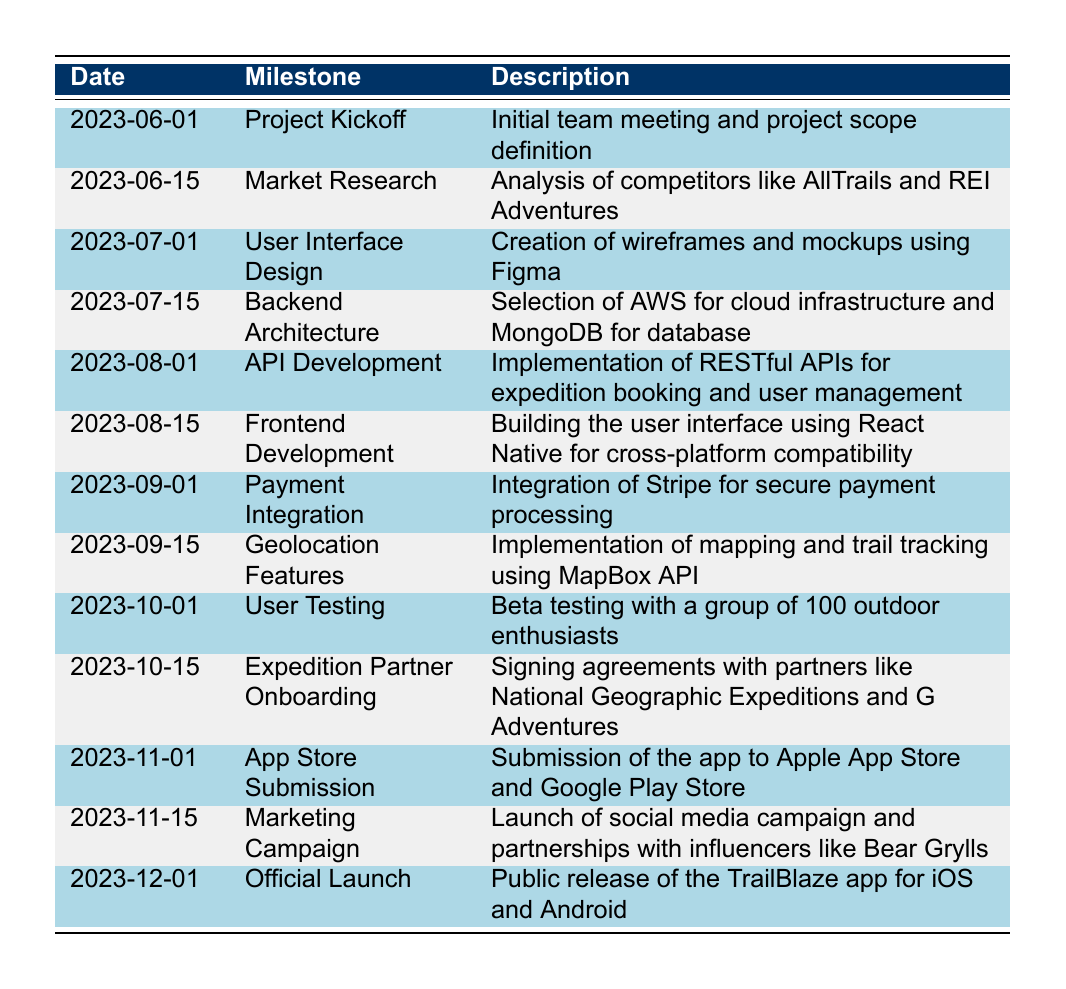What milestone is scheduled for August 1, 2023? The table shows the timeline of the project, and by looking at the date column for August 1, 2023, we can see that the corresponding milestone is "API Development."
Answer: API Development What is the description of the milestone on November 15, 2023? By checking the row for November 15, 2023, we find that the milestone is "Marketing Campaign" and the description is "Launch of social media campaign and partnerships with influencers like Bear Grylls."
Answer: Launch of social media campaign and partnerships with influencers like Bear Grylls How many milestones are scheduled before user testing? By counting the milestones listed before the date "2023-10-01" (User Testing), we can see there are seven milestones: Project Kickoff, Market Research, User Interface Design, Backend Architecture, API Development, Frontend Development, and Payment Integration.
Answer: 7 Is there any milestone scheduled after the official launch? The last entry in the table is for December 1, 2023, which indicates the Official Launch. Since there are no entries after this date in the table, the answer is no.
Answer: No Which milestone comes just before payment integration? Looking at the date of payment integration, which is September 1, 2023, we can see that the previous milestone is "Frontend Development" scheduled for August 15, 2023.
Answer: Frontend Development How many days are there between the Project Kickoff and the Official Launch? The Project Kickoff is on June 1, 2023, and the Official Launch is on December 1, 2023. There are 6 months (June to November) and 1 day in December, which is a total of 183 days (30 days for June, 31 for July, 31 for August, 30 for September, 31 for October, and 30 for November).
Answer: 183 days What percentage of the timeline includes milestones focused specifically on development (Design, Architecture, API, Frontend, Payment)? The total number of milestones in the timeline is 13. The milestones that are focused on development are User Interface Design, Backend Architecture, API Development, Frontend Development, and Payment Integration, totaling 5. Thus, the percentage is (5/13) * 100 = 38.46%.
Answer: 38.46% Which expedition partners were onboarded by October 15, 2023? By examining the milestone scheduled for October 15, 2023, we see that it is "Expedition Partner Onboarding," which mentions partners like National Geographic Expeditions and G Adventures.
Answer: National Geographic Expeditions and G Adventures 